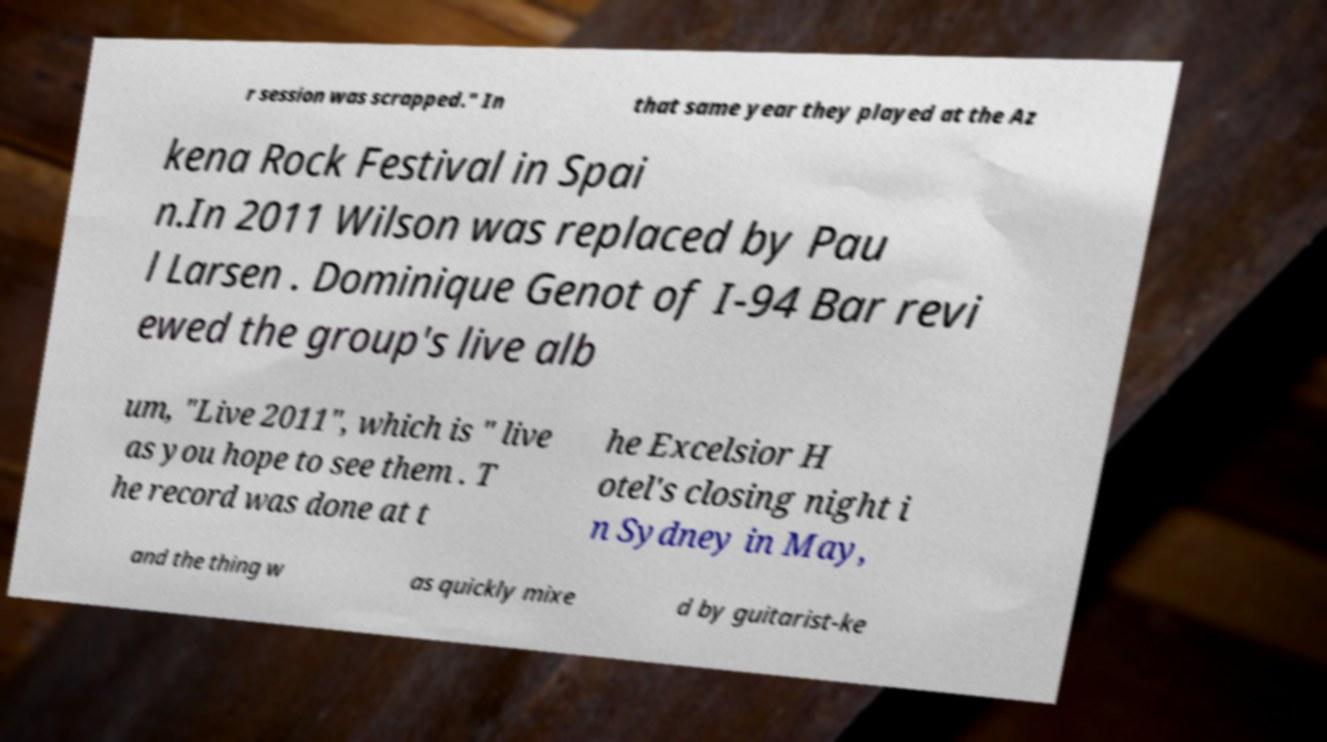Can you read and provide the text displayed in the image?This photo seems to have some interesting text. Can you extract and type it out for me? r session was scrapped." In that same year they played at the Az kena Rock Festival in Spai n.In 2011 Wilson was replaced by Pau l Larsen . Dominique Genot of I-94 Bar revi ewed the group's live alb um, "Live 2011", which is " live as you hope to see them . T he record was done at t he Excelsior H otel's closing night i n Sydney in May, and the thing w as quickly mixe d by guitarist-ke 